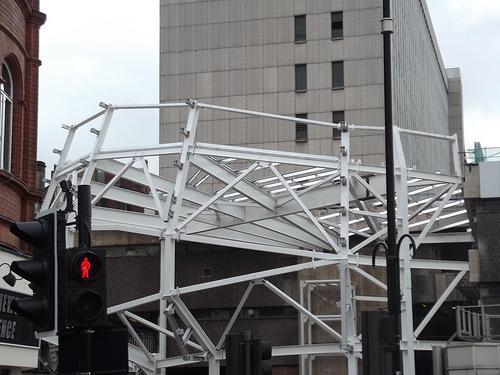How many windows in the gray building are visible?
Give a very brief answer. 6. How many street lights are lit?
Give a very brief answer. 1. 